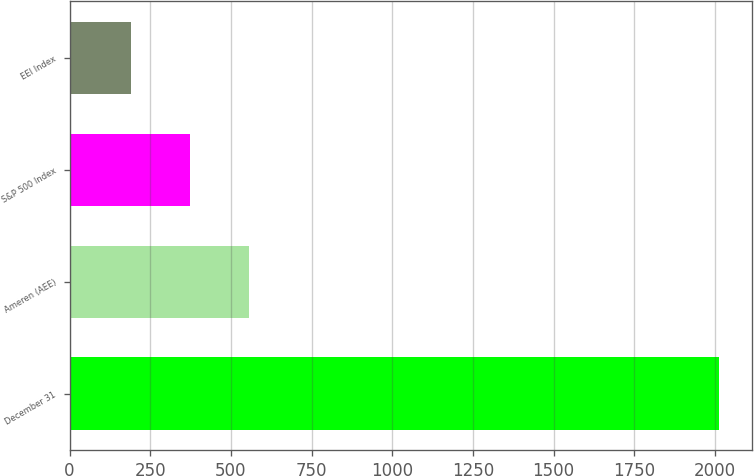<chart> <loc_0><loc_0><loc_500><loc_500><bar_chart><fcel>December 31<fcel>Ameren (AEE)<fcel>S&P 500 Index<fcel>EEI Index<nl><fcel>2014<fcel>555.62<fcel>373.32<fcel>191.02<nl></chart> 